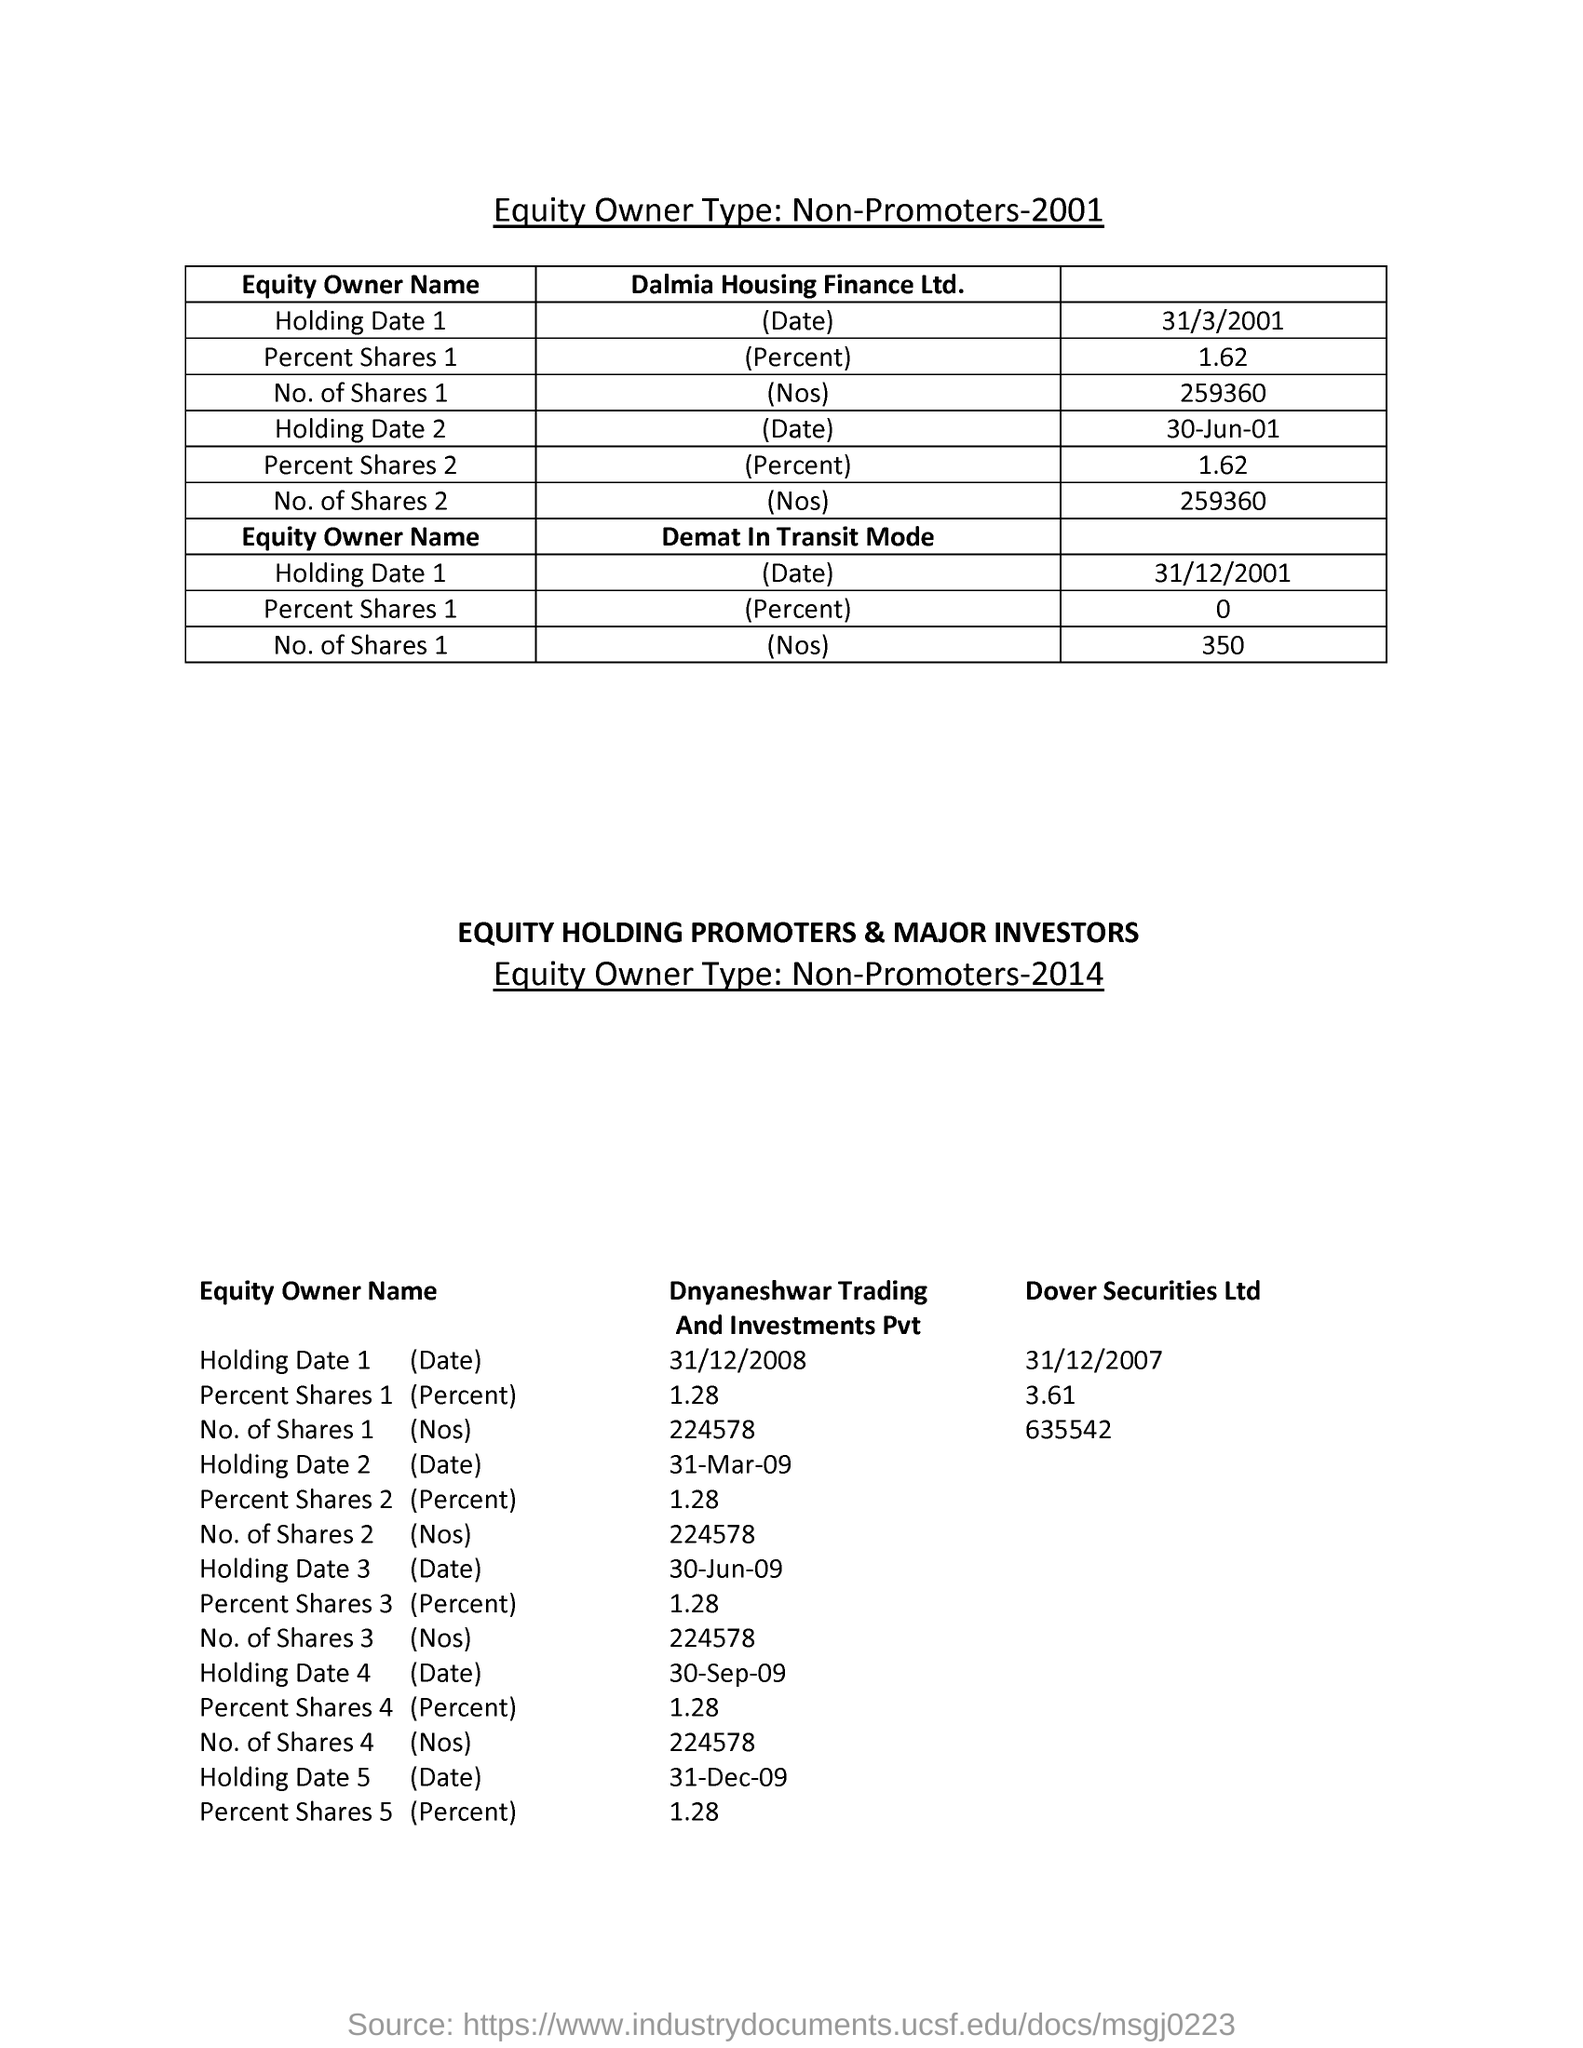What is the percentage of shares held by Dover Securities Ltd on 31/12/2007??
Your answer should be very brief. 3.61. What is the number of shares held by Dover Securities Ltd on 31/12/2007?
Make the answer very short. 635542. What is the percentage of shares held by Demat in Transit mode on 31/12/2001?
Offer a terse response. 0. 